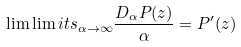<formula> <loc_0><loc_0><loc_500><loc_500>\lim \lim i t s _ { \alpha \to \infty } \frac { D _ { \alpha } P ( z ) } { \alpha } = { P } ^ { \prime } ( z )</formula> 